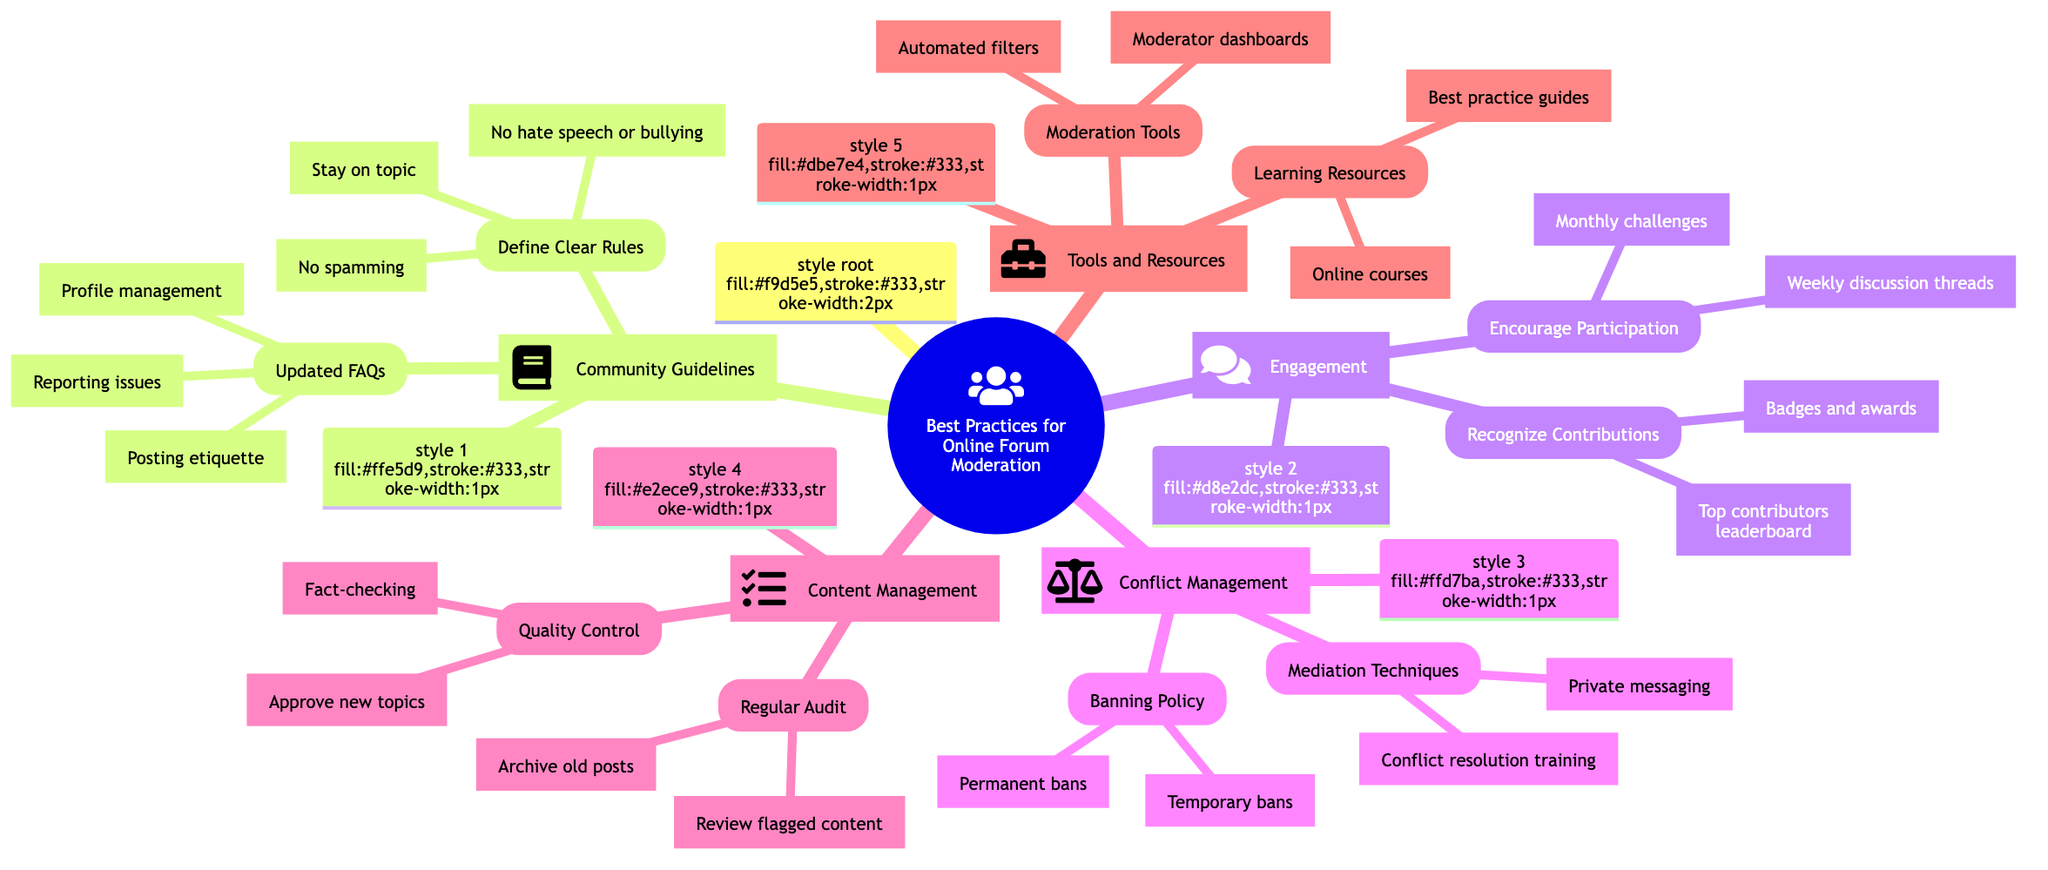What is the main topic of the diagram? The title at the root of the diagram clearly states "Best Practices for Online Forum Moderation," which is the central theme of the mind map.
Answer: Best Practices for Online Forum Moderation How many main sections are there in the diagram? By examining the first-level nodes (1, 2, 3, 4, 5), we can count five distinct sections: Community Guidelines, Engagement, Conflict Management, Content Management, and Tools and Resources.
Answer: 5 What are the three rules listed under "Define Clear Rules"? The sub-nodes under "Define Clear Rules" include three specific phrases: "No spamming," "Stay on topic," and "No hate speech or bullying." Collectively, they represent the guidelines for online behavior.
Answer: No spamming, Stay on topic, No hate speech or bullying Which section includes techniques for mediation? The node "Mediation Techniques" is found under the "Conflict Management" section, indicating that it specifically addresses the methods used to resolve disputes among forum members.
Answer: Conflict Management What activities are suggested to encourage participation in the forum? Reviewing the "Encourage Participation" node shows two specific activities listed: "Weekly discussion threads" and "Monthly challenges," designed to engage forum members actively.
Answer: Weekly discussion threads, Monthly challenges What type of bans are mentioned in the "Banning Policy"? The "Banning Policy" node lists two types of bans: "Temporary bans" and "Permanent bans," indicating the range of disciplinary actions available for moderators.
Answer: Temporary bans, Permanent bans What is included in the "Learning Resources" section? The "Learning Resources" node provides two options: "Online courses" and "Best practice guides," which serve as resources for moderators to improve their skills.
Answer: Online courses, Best practice guides How is content quality maintained according to the diagram? The "Quality Control" node outlines two key practices: "Approve new topics" and "Fact-checking," which ensure that the content shared in the forum meets a certain standard.
Answer: Approve new topics, Fact-checking What is one of the tools mentioned under "Moderation Tools"? Among the sub-nodes listed under "Moderation Tools," "Automated filters" is specifically mentioned as a tool that aids in managing forum content and user behavior.
Answer: Automated filters 